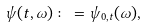<formula> <loc_0><loc_0><loc_500><loc_500>\psi ( t , \omega ) \colon = \psi _ { 0 , t } ( \omega ) ,</formula> 